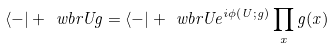<formula> <loc_0><loc_0><loc_500><loc_500>\langle - | + \ w b r U g = \langle - | + \ w b r U e ^ { i \phi ( U ; g ) } \prod _ { x } g ( x )</formula> 